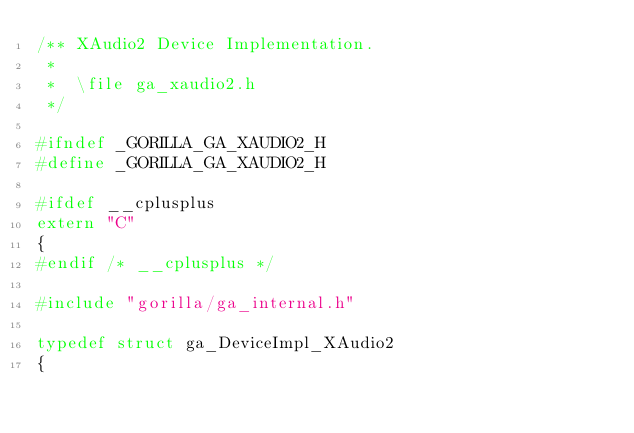<code> <loc_0><loc_0><loc_500><loc_500><_C_>/** XAudio2 Device Implementation.
 *
 *  \file ga_xaudio2.h
 */

#ifndef _GORILLA_GA_XAUDIO2_H
#define _GORILLA_GA_XAUDIO2_H

#ifdef __cplusplus
extern "C"
{
#endif /* __cplusplus */

#include "gorilla/ga_internal.h"

typedef struct ga_DeviceImpl_XAudio2
{</code> 